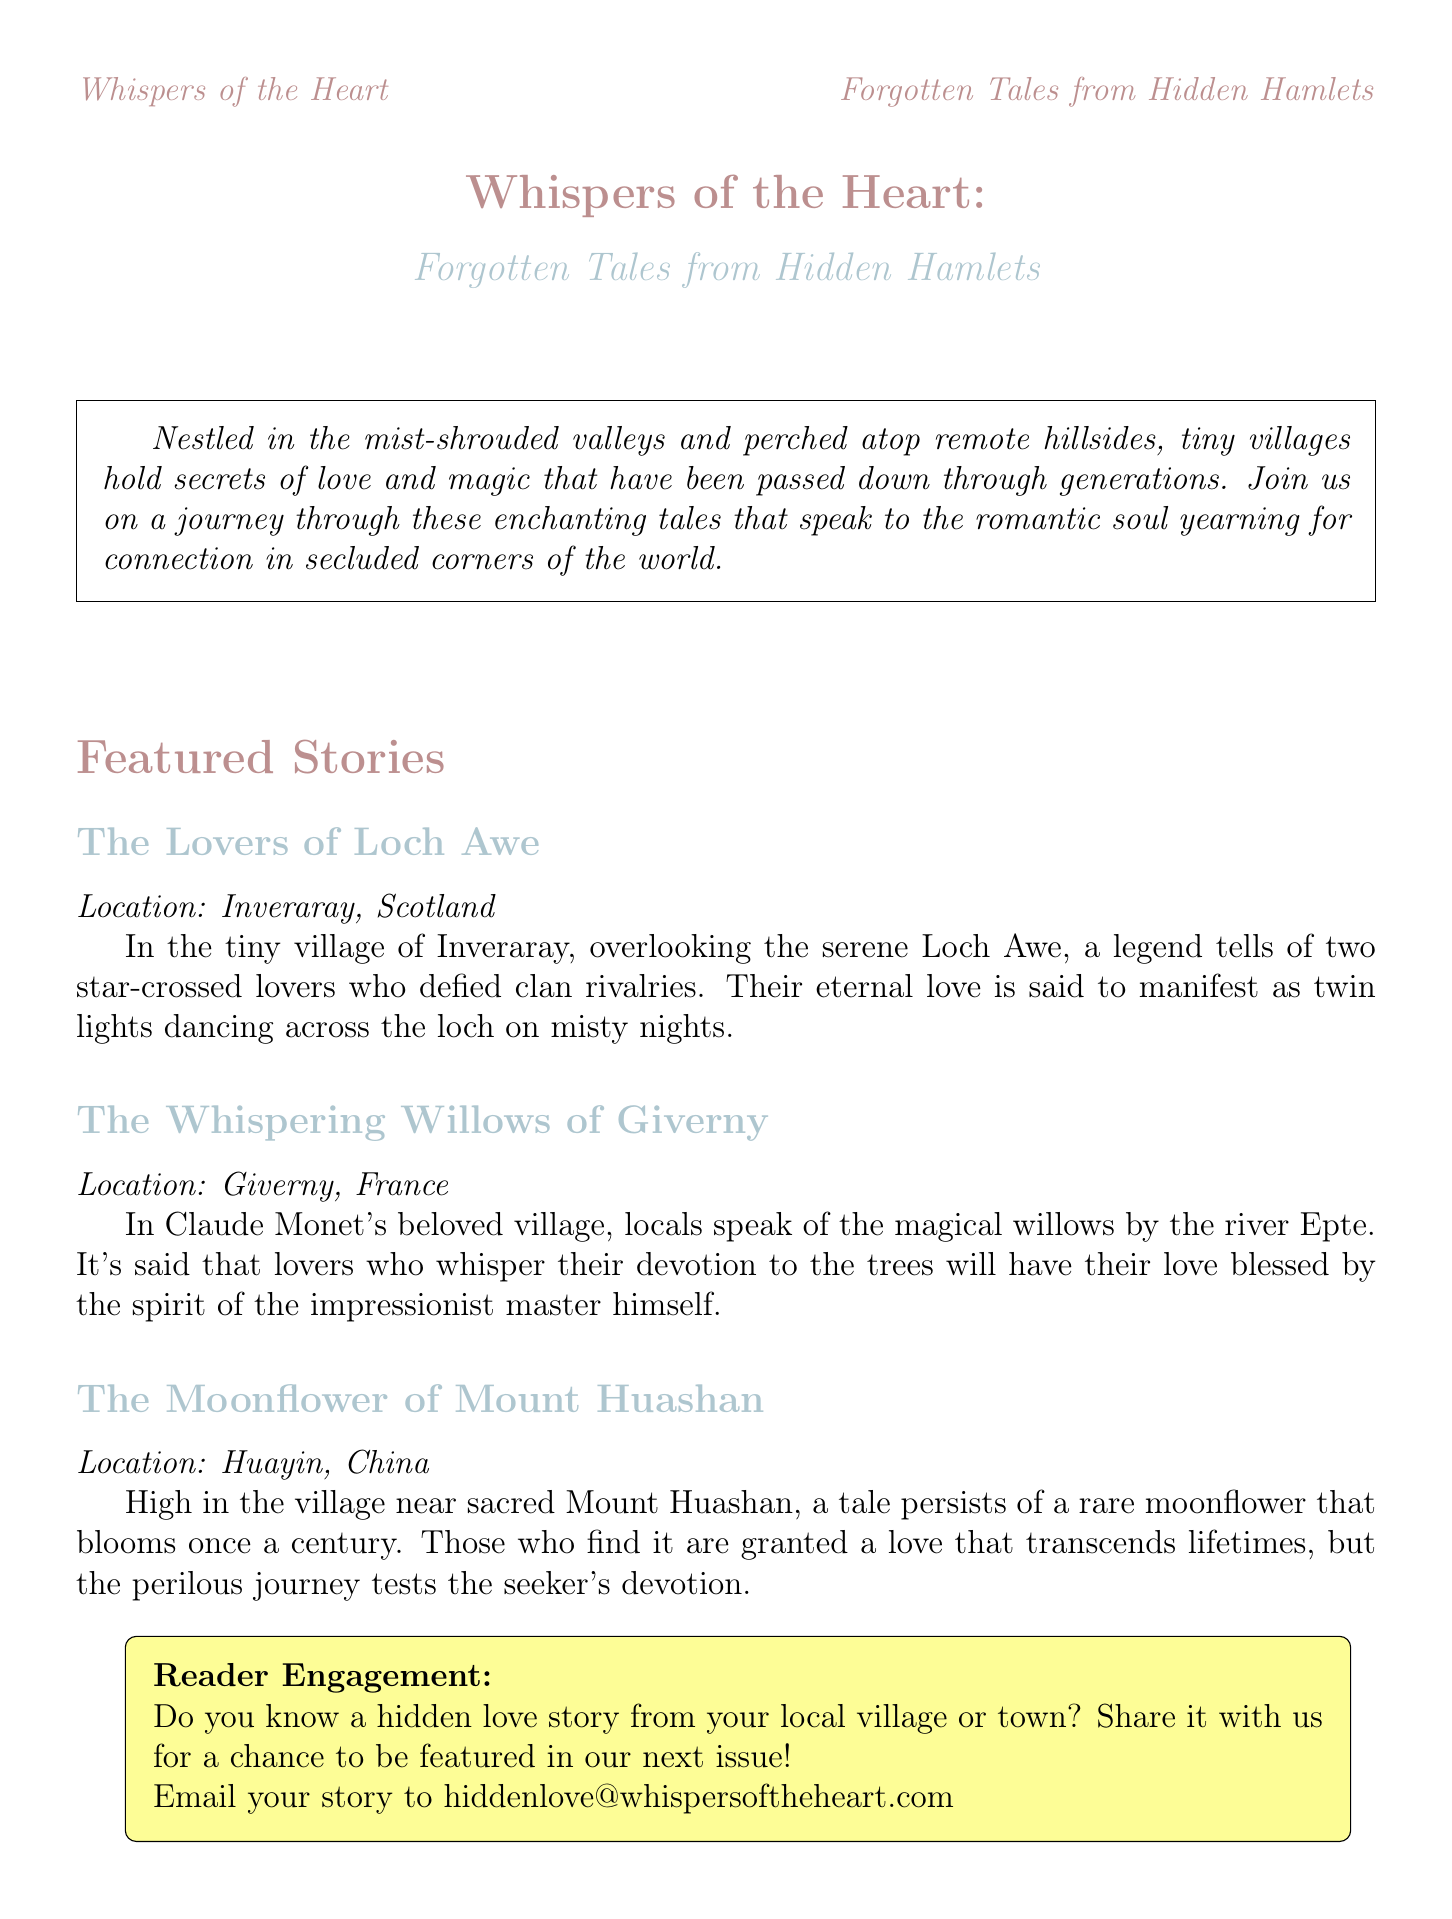What is the title of the newsletter? The title is stated at the top of the document.
Answer: Whispers of the Heart: Forgotten Tales from Hidden Hamlets Which village is associated with the Lovers of Loch Awe? The location is provided in the summary of the featured story.
Answer: Inveraray, Scotland What is the magical plant mentioned in the story of Mount Huashan? The summary specifies the unique flower in the tale.
Answer: Moonflower What type of art is featured in the Cultural Spotlight? The description of the cultural spotlight highlights an artistic craft.
Answer: Tapestries What is the reader engagement prompt about? The engagement section asks for local love stories.
Answer: Hidden love story submission How many featured stories are in the newsletter? The count of featured stories is listed in the document.
Answer: Three What natural feature is highlighted in the setting of the Lovers of Loch Awe? The legend's setting gives a prominent natural element.
Answer: Loch Awe What is the artistic style mentioned in the Whispering Willows of Giverny? The description refers to a notable artistic movement.
Answer: Impressionist In which country is the village of Oia located? The document specifies the country for the travel section.
Answer: Greece 